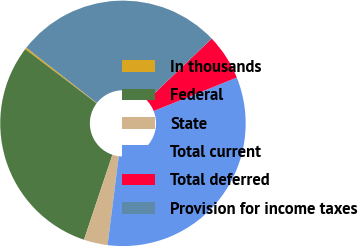<chart> <loc_0><loc_0><loc_500><loc_500><pie_chart><fcel>In thousands<fcel>Federal<fcel>State<fcel>Total current<fcel>Total deferred<fcel>Provision for income taxes<nl><fcel>0.24%<fcel>30.19%<fcel>3.14%<fcel>33.09%<fcel>6.04%<fcel>27.29%<nl></chart> 